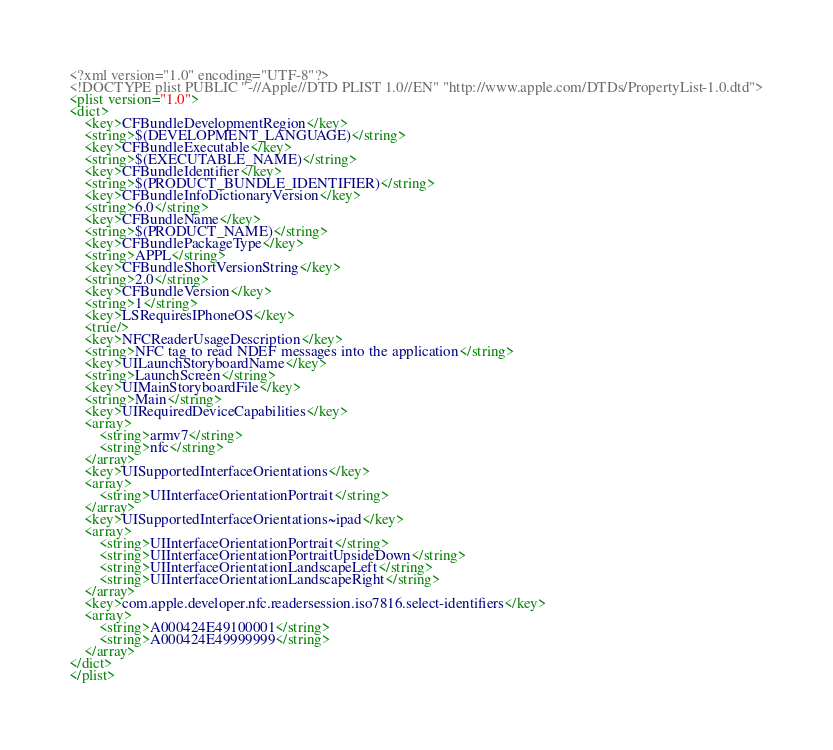Convert code to text. <code><loc_0><loc_0><loc_500><loc_500><_XML_><?xml version="1.0" encoding="UTF-8"?>
<!DOCTYPE plist PUBLIC "-//Apple//DTD PLIST 1.0//EN" "http://www.apple.com/DTDs/PropertyList-1.0.dtd">
<plist version="1.0">
<dict>
	<key>CFBundleDevelopmentRegion</key>
	<string>$(DEVELOPMENT_LANGUAGE)</string>
	<key>CFBundleExecutable</key>
	<string>$(EXECUTABLE_NAME)</string>
	<key>CFBundleIdentifier</key>
	<string>$(PRODUCT_BUNDLE_IDENTIFIER)</string>
	<key>CFBundleInfoDictionaryVersion</key>
	<string>6.0</string>
	<key>CFBundleName</key>
	<string>$(PRODUCT_NAME)</string>
	<key>CFBundlePackageType</key>
	<string>APPL</string>
	<key>CFBundleShortVersionString</key>
	<string>2.0</string>
	<key>CFBundleVersion</key>
	<string>1</string>
	<key>LSRequiresIPhoneOS</key>
	<true/>
	<key>NFCReaderUsageDescription</key>
	<string>NFC tag to read NDEF messages into the application</string>
	<key>UILaunchStoryboardName</key>
	<string>LaunchScreen</string>
	<key>UIMainStoryboardFile</key>
	<string>Main</string>
	<key>UIRequiredDeviceCapabilities</key>
	<array>
		<string>armv7</string>
		<string>nfc</string>
	</array>
	<key>UISupportedInterfaceOrientations</key>
	<array>
		<string>UIInterfaceOrientationPortrait</string>
	</array>
	<key>UISupportedInterfaceOrientations~ipad</key>
	<array>
		<string>UIInterfaceOrientationPortrait</string>
		<string>UIInterfaceOrientationPortraitUpsideDown</string>
		<string>UIInterfaceOrientationLandscapeLeft</string>
		<string>UIInterfaceOrientationLandscapeRight</string>
	</array>
	<key>com.apple.developer.nfc.readersession.iso7816.select-identifiers</key>
	<array>
		<string>A000424E49100001</string>
        <string>A000424E49999999</string>
	</array>
</dict>
</plist>
</code> 